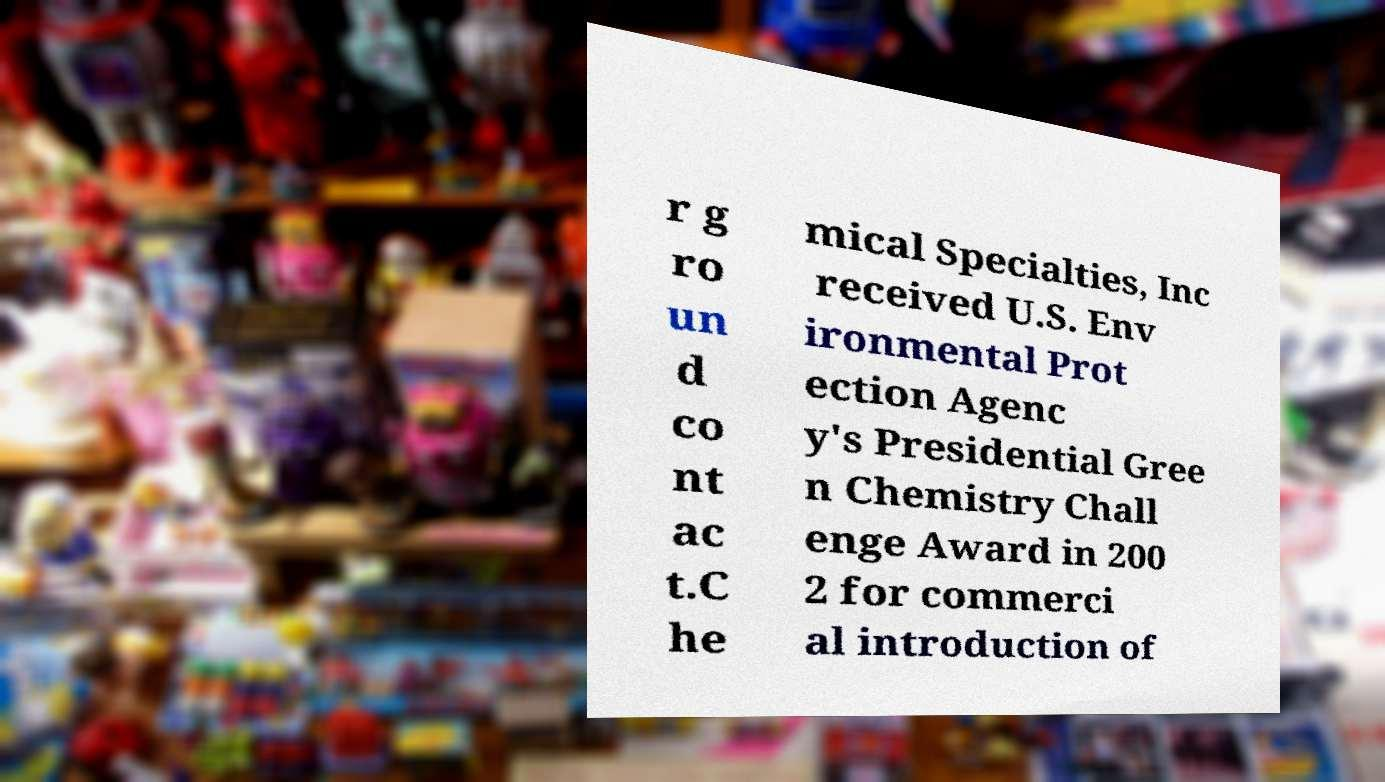Please identify and transcribe the text found in this image. r g ro un d co nt ac t.C he mical Specialties, Inc received U.S. Env ironmental Prot ection Agenc y's Presidential Gree n Chemistry Chall enge Award in 200 2 for commerci al introduction of 